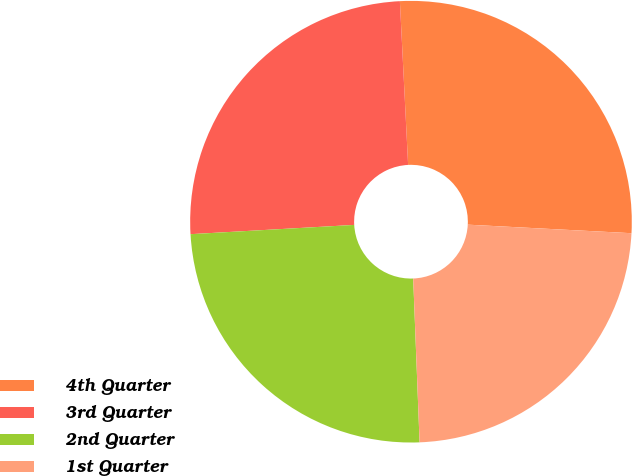Convert chart. <chart><loc_0><loc_0><loc_500><loc_500><pie_chart><fcel>4th Quarter<fcel>3rd Quarter<fcel>2nd Quarter<fcel>1st Quarter<nl><fcel>26.63%<fcel>25.1%<fcel>24.72%<fcel>23.55%<nl></chart> 